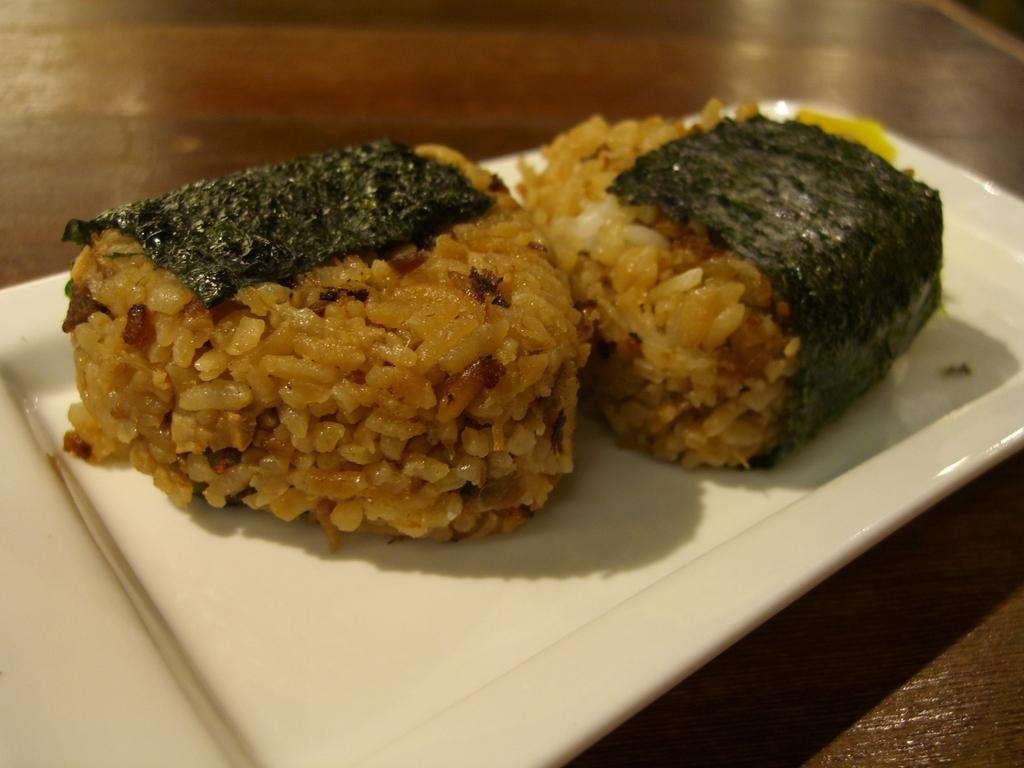What is on the plate that is visible in the image? There is a plate with food in the image. What color is the plate? The plate is white. What colors can be seen in the food on the plate? The food has brown and green colors. Where is the plate located in the image? The plate is on a table. What type of bomb is present in the image? There is no bomb present in the image; it features a plate with food on a table. What time of day is the smash supposed to occur in the image? There is no mention of a smash or any destructive event in the image; it simply shows a plate with food on a table. 